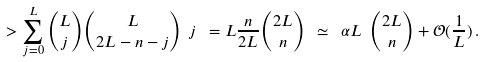<formula> <loc_0><loc_0><loc_500><loc_500>> \sum ^ { L } _ { j = 0 } \binom { L } { j } \binom { L } { 2 L - n - j } \ j \ = L \frac { n } { 2 L } \binom { 2 L } { n } \ \simeq \ \alpha L \ \binom { 2 L } { n } + \mathcal { O } ( \frac { 1 } { L } ) \, .</formula> 